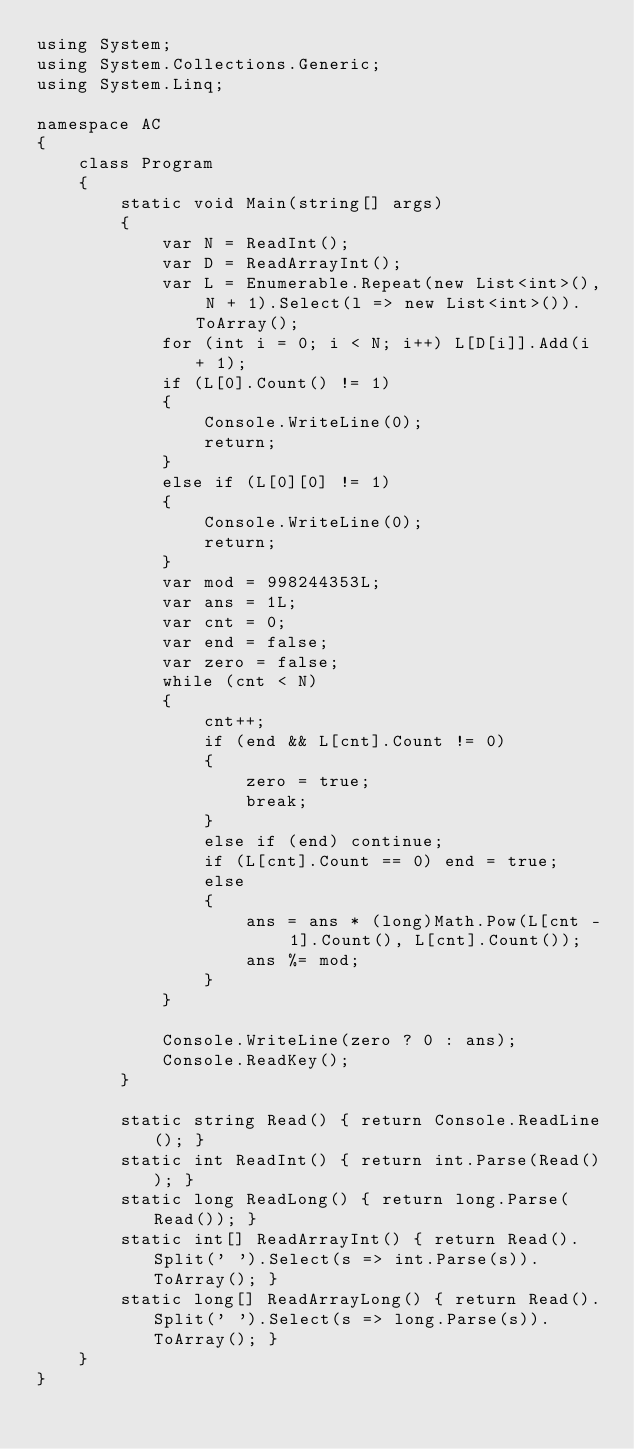Convert code to text. <code><loc_0><loc_0><loc_500><loc_500><_C#_>using System;
using System.Collections.Generic;
using System.Linq;

namespace AC
{
    class Program
    {
        static void Main(string[] args)
        {
            var N = ReadInt();
            var D = ReadArrayInt();
            var L = Enumerable.Repeat(new List<int>(), N + 1).Select(l => new List<int>()).ToArray();
            for (int i = 0; i < N; i++) L[D[i]].Add(i + 1);
            if (L[0].Count() != 1)
            {
                Console.WriteLine(0);
                return;
            }
            else if (L[0][0] != 1)
            {
                Console.WriteLine(0);
                return;
            }
            var mod = 998244353L;
            var ans = 1L;
            var cnt = 0;
            var end = false;
            var zero = false;
            while (cnt < N)
            {
                cnt++;
                if (end && L[cnt].Count != 0)
                {
                    zero = true;
                    break;
                }
                else if (end) continue;
                if (L[cnt].Count == 0) end = true;
                else
                {
                    ans = ans * (long)Math.Pow(L[cnt - 1].Count(), L[cnt].Count());
                    ans %= mod;
                }
            }

            Console.WriteLine(zero ? 0 : ans);
            Console.ReadKey();
        }

        static string Read() { return Console.ReadLine(); }
        static int ReadInt() { return int.Parse(Read()); }
        static long ReadLong() { return long.Parse(Read()); }
        static int[] ReadArrayInt() { return Read().Split(' ').Select(s => int.Parse(s)).ToArray(); }
        static long[] ReadArrayLong() { return Read().Split(' ').Select(s => long.Parse(s)).ToArray(); }
    }
}</code> 